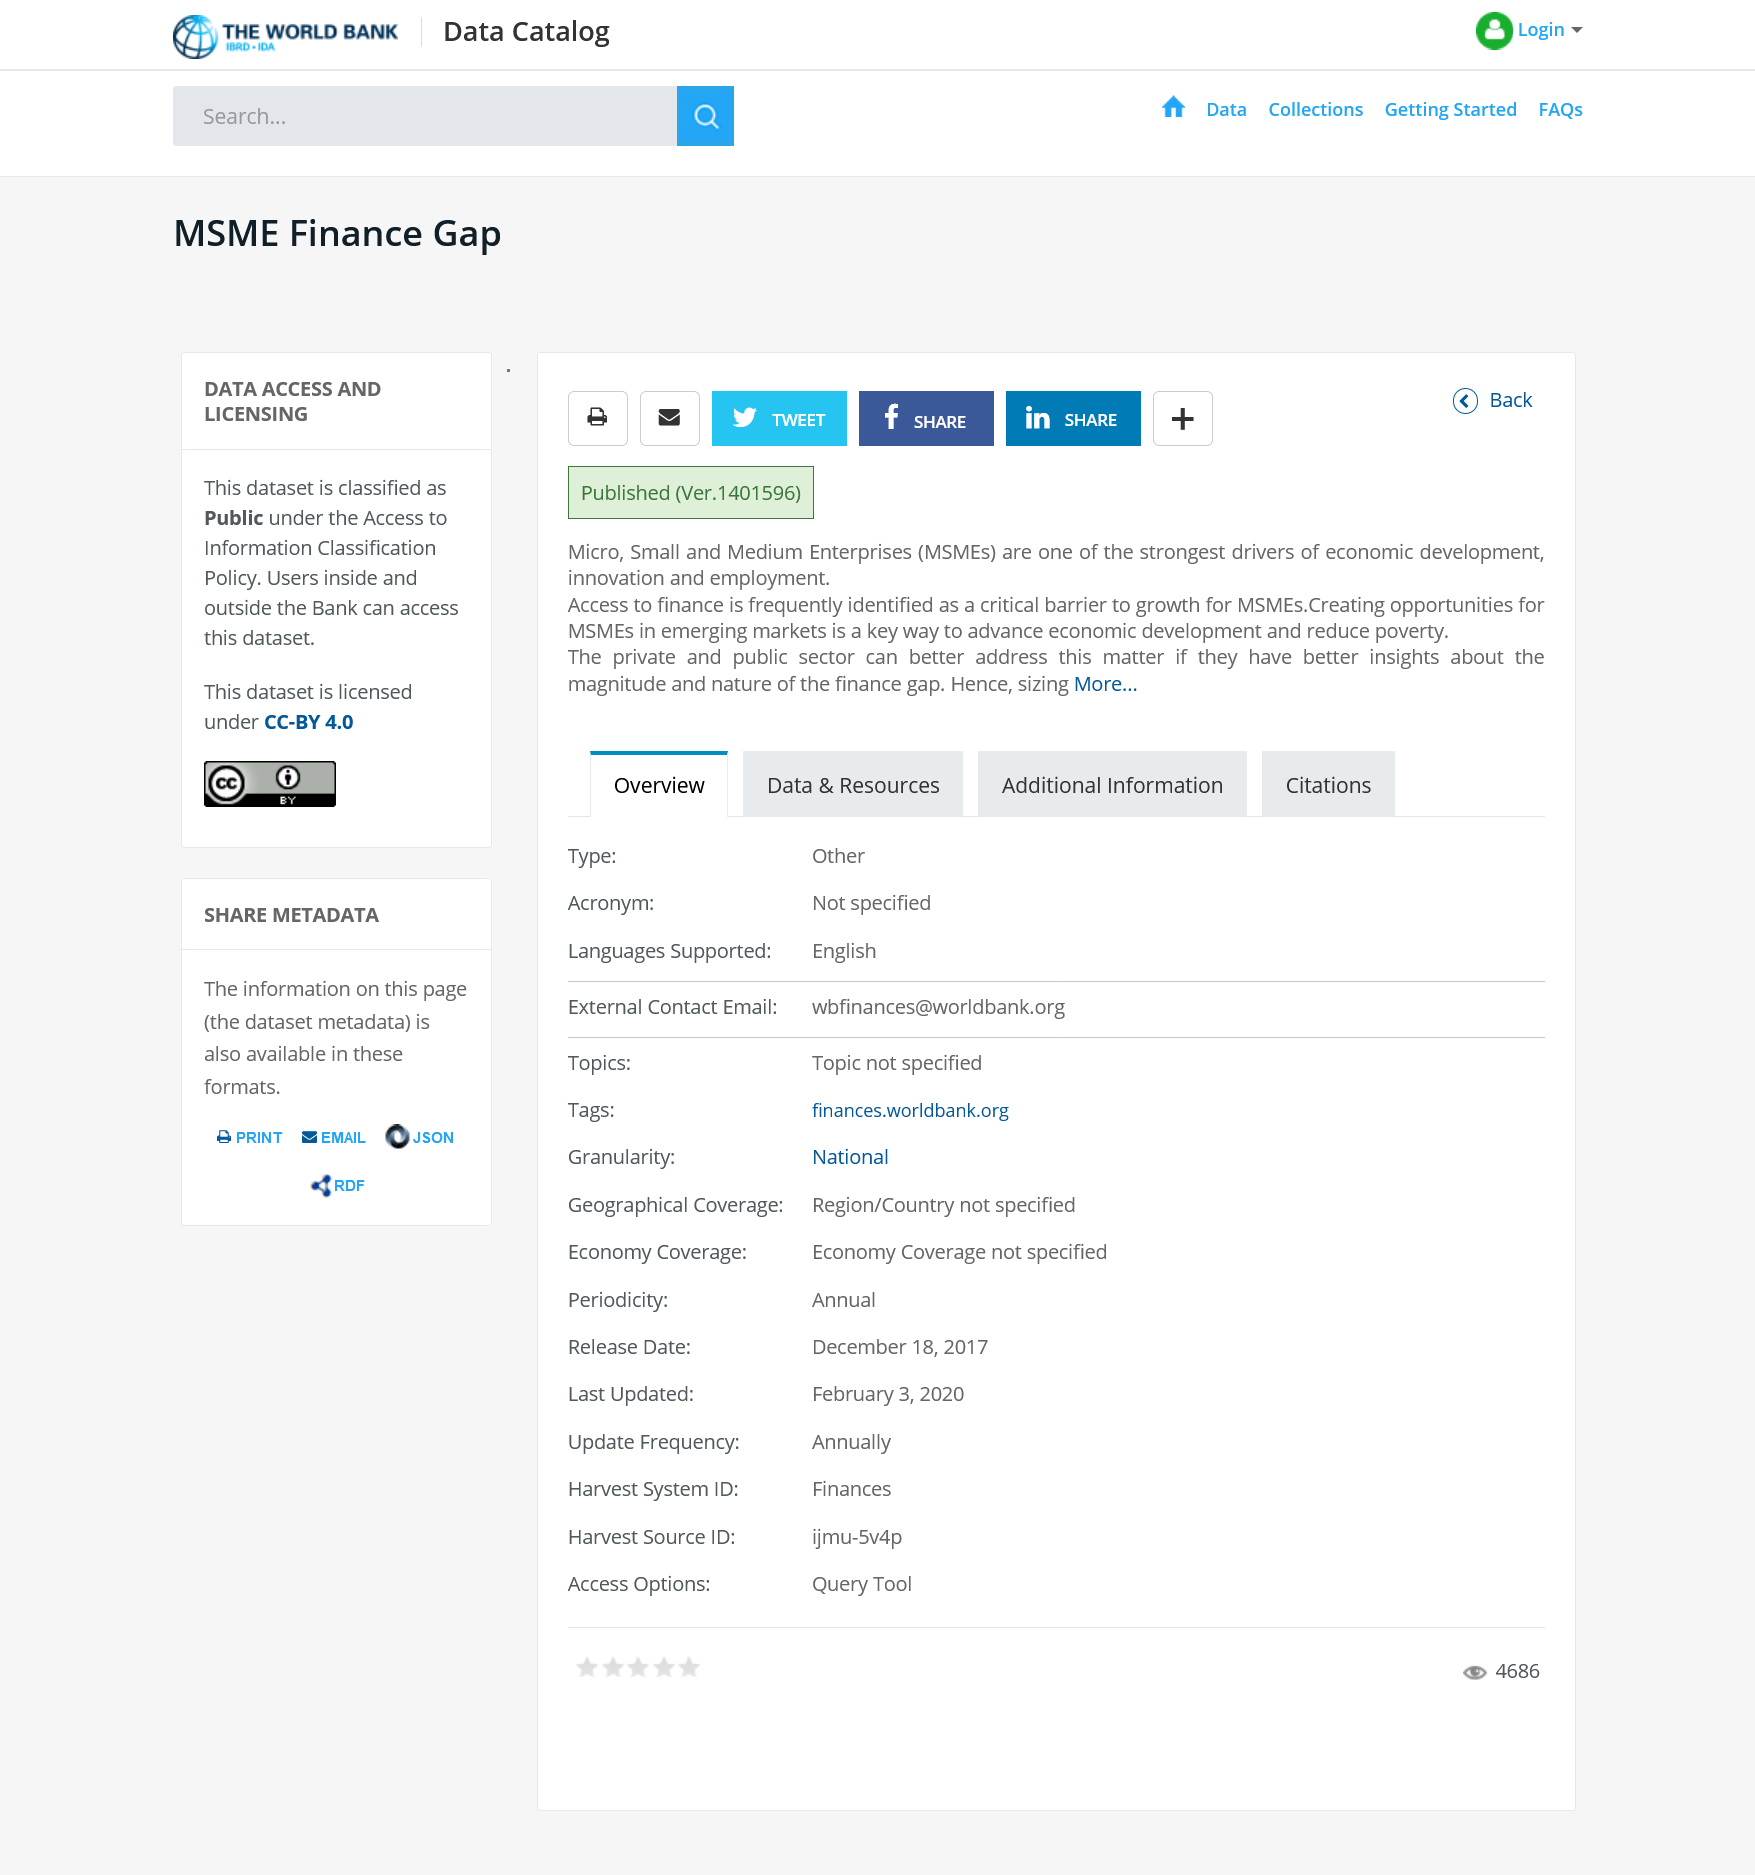Point out several critical features in this image. Access to finance is a critical barrier to growth for MSMEs. The dataset is classified as public, meaning it is available for use and access by the general public. Micro, small, and medium enterprises (MSMEs) are abbreviated as such. 